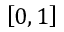Convert formula to latex. <formula><loc_0><loc_0><loc_500><loc_500>\left [ 0 , 1 \right ]</formula> 